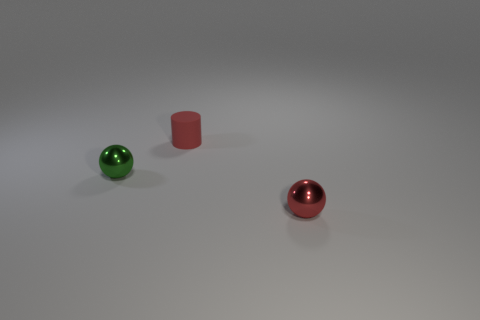Add 1 big brown things. How many objects exist? 4 Subtract all green spheres. How many spheres are left? 1 Subtract all cylinders. How many objects are left? 2 Subtract all brown balls. Subtract all brown cylinders. How many balls are left? 2 Subtract all purple spheres. How many brown cylinders are left? 0 Subtract all green spheres. Subtract all small green balls. How many objects are left? 1 Add 3 tiny things. How many tiny things are left? 6 Add 1 small metallic objects. How many small metallic objects exist? 3 Subtract 0 cyan spheres. How many objects are left? 3 Subtract 1 spheres. How many spheres are left? 1 